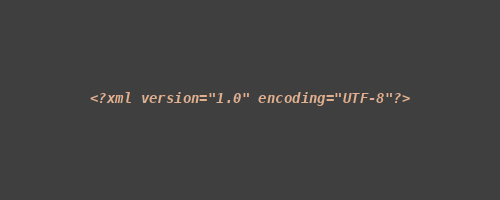<code> <loc_0><loc_0><loc_500><loc_500><_XML_><?xml version="1.0" encoding="UTF-8"?></code> 